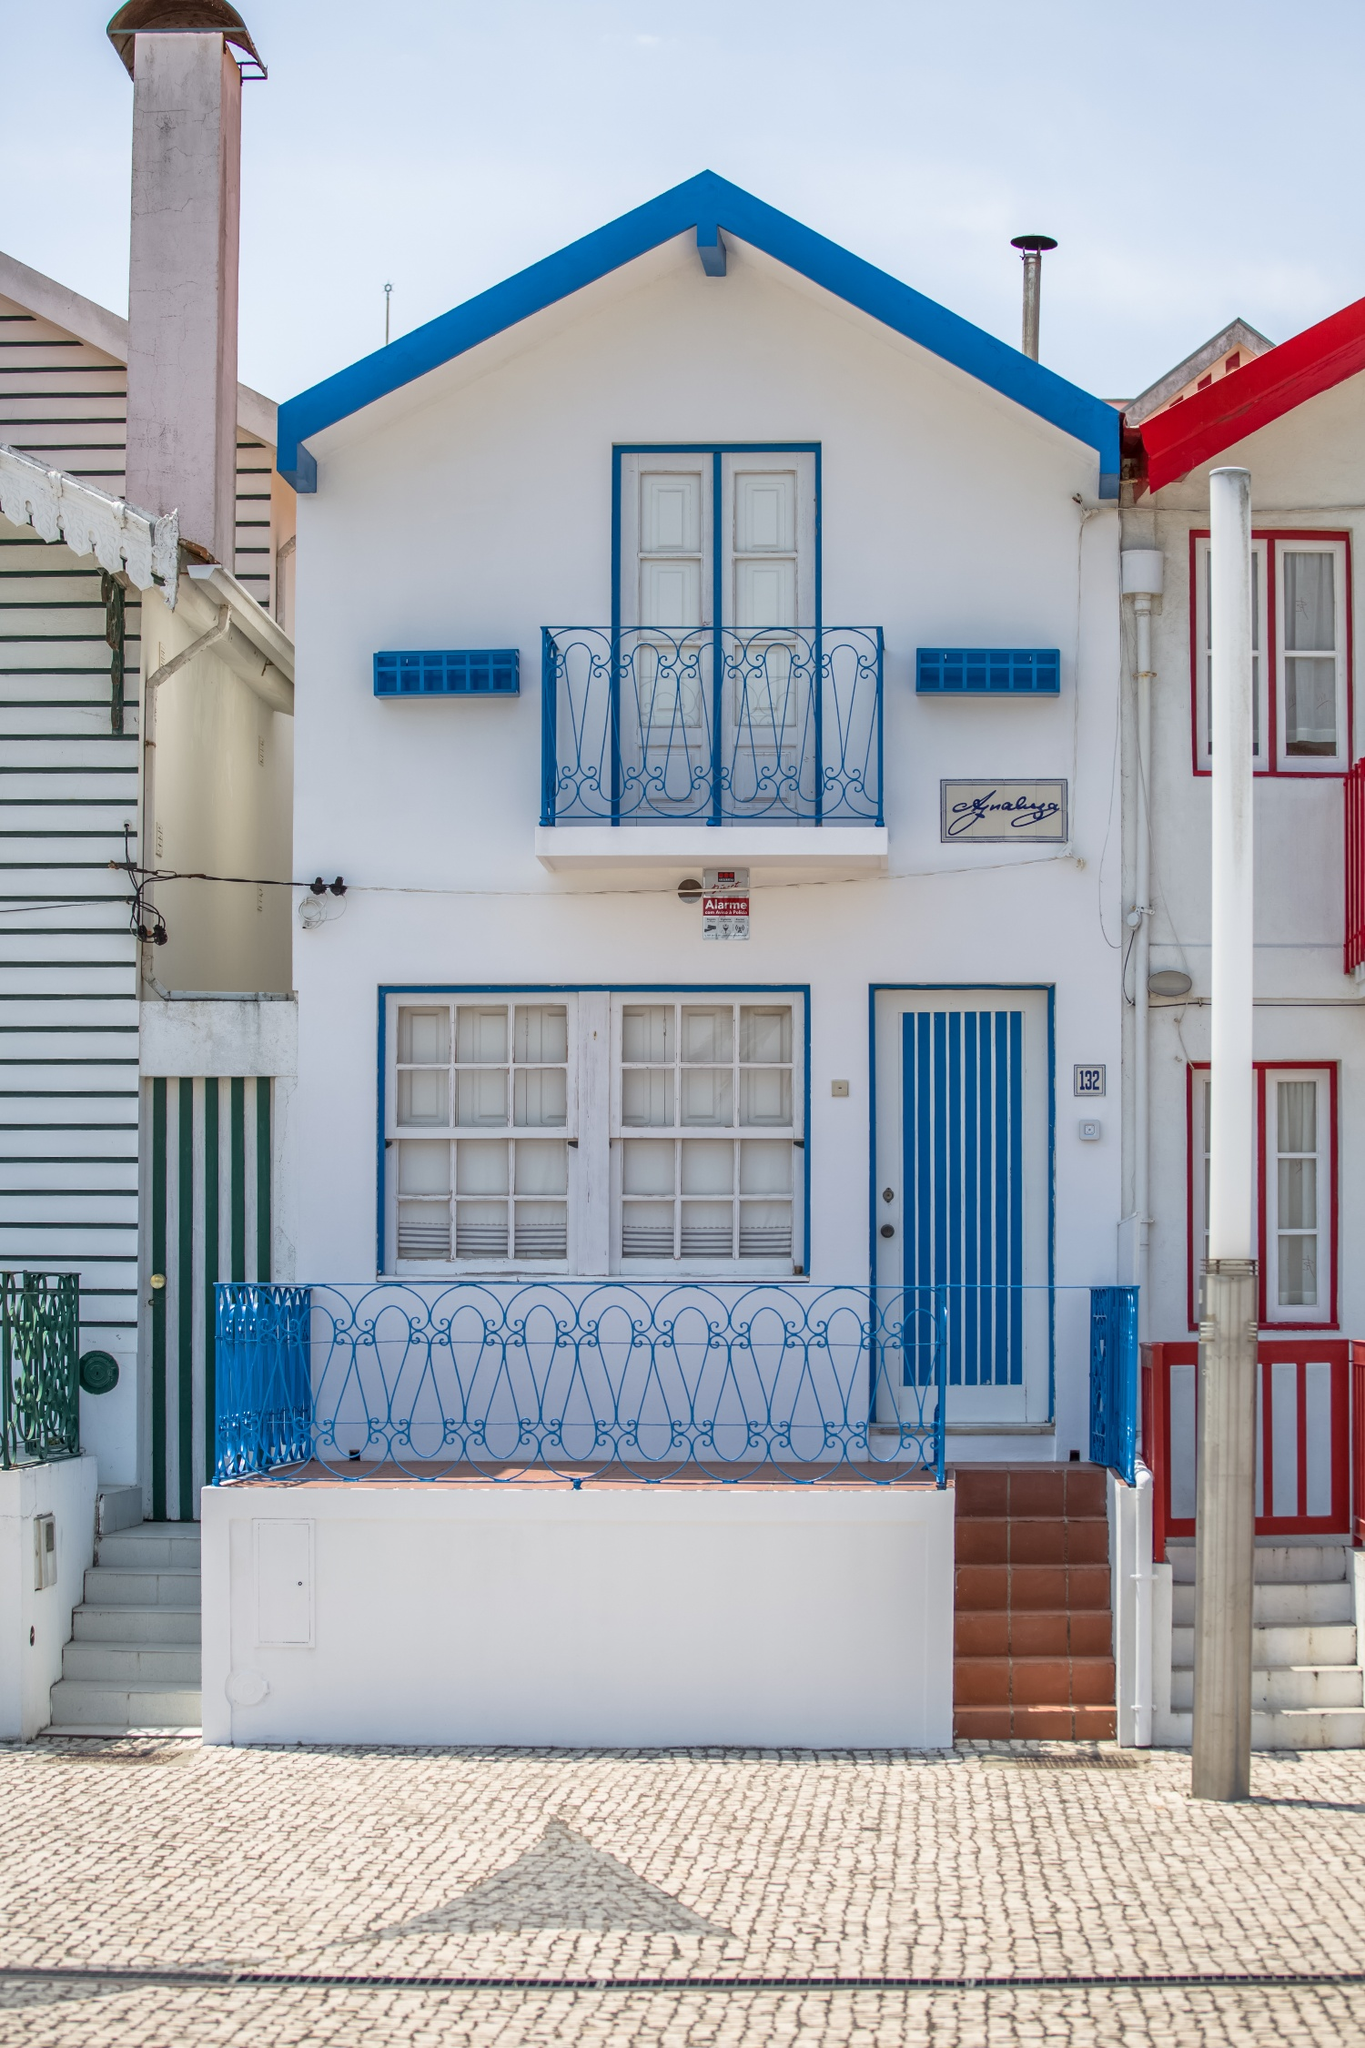Can you tell more about the cultural significance of having such a distinct façade in coastal towns? Distinct façades in coastal towns often hold deep cultural significance, reflecting the community's identity and heritage. In many cases, these unique exteriors are a blend of functionality and local artistic expressions, showcasing traditional crafts and influences from historical periods. For instance, the use of particular colors or balcony styles may echo the town's maritime history or its ties to certain epochs or ruling cultures. These architectural features not only enhance the town's visual appeal but also strengthen communal ties and pride, serving as a daily reminder of the town's unique character and stories. 